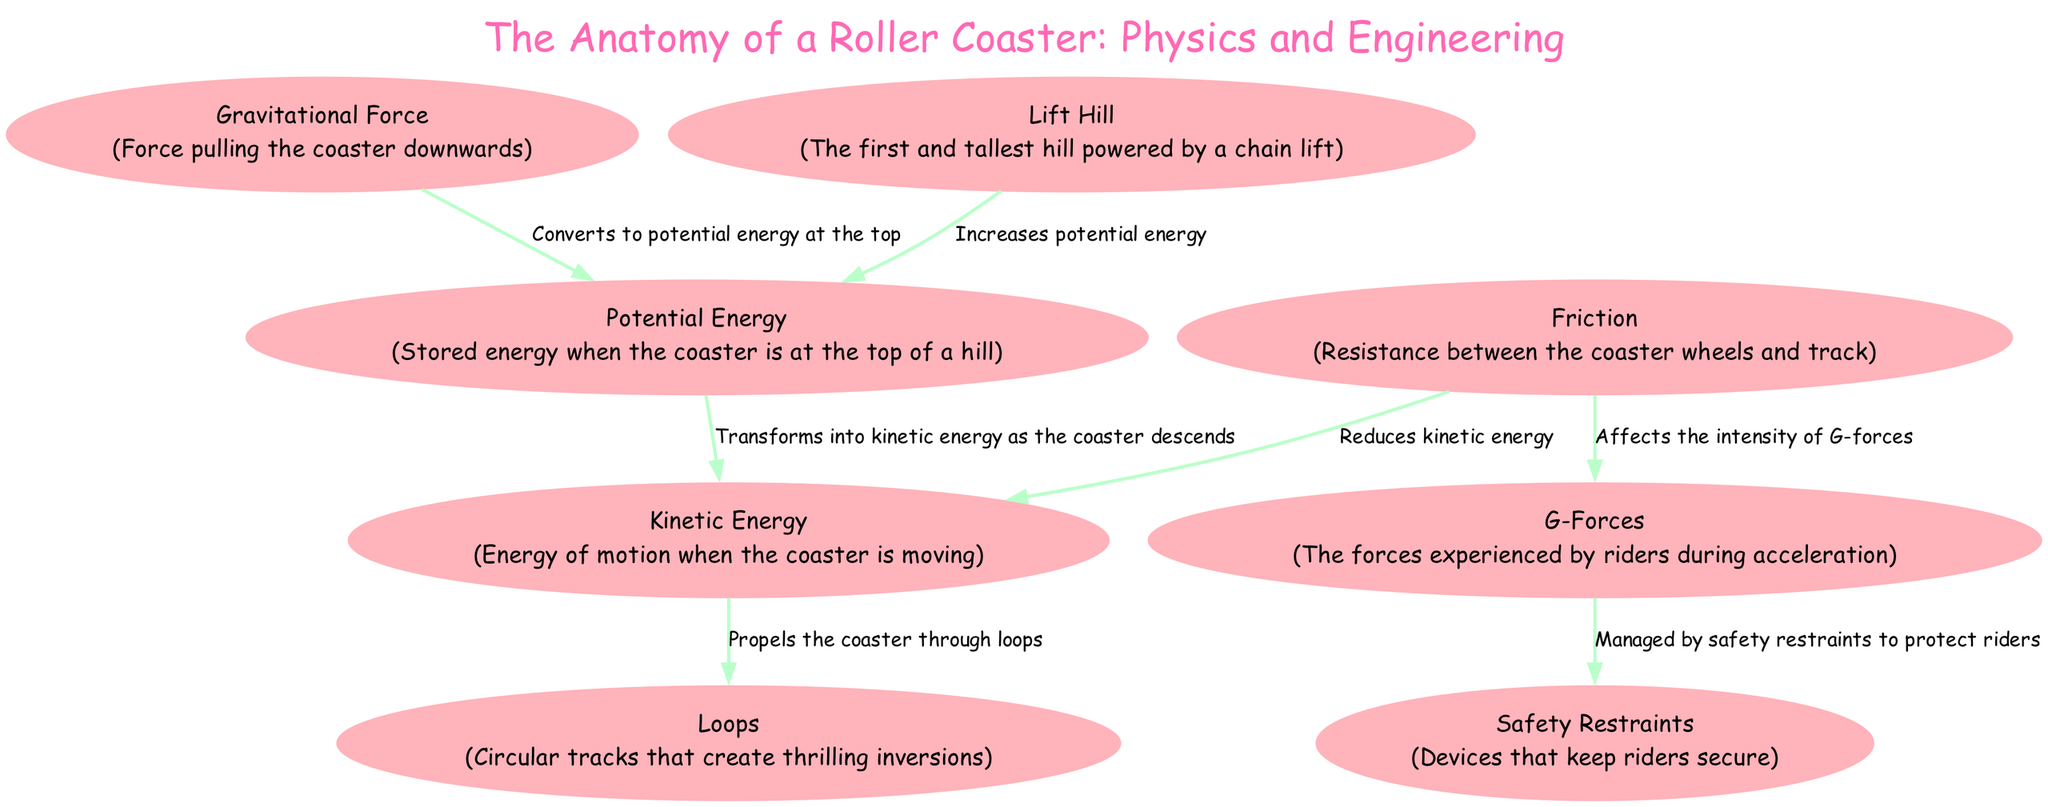What pulls the coaster downwards? The diagram identifies "Gravitational Force" as the force that pulls the coaster downwards.
Answer: Gravitational Force What increases when the coaster reaches the top of the hill? The diagram shows that "Potential Energy" increases when the coaster is at the top of the hill.
Answer: Potential Energy How many nodes are in the diagram? Counting the nodes listed in the diagram, there are a total of 8 nodes.
Answer: 8 What energy is transformed as the coaster descends? The diagram states that "Potential Energy" transforms into "Kinetic Energy" as the coaster descends.
Answer: Kinetic Energy What is affected by friction? According to the diagram, "G-Forces" are affected by friction, as friction influences the intensity of G-Forces during the ride.
Answer: G-Forces How does the lift hill impact potential energy? The "Lift Hill" is shown to increase "Potential Energy," indicating that the action of climbing this hill raises the stored energy of the coaster.
Answer: Increases Potential Energy What type of forces do riders experience during acceleration? The diagram defines "G-Forces" as the type of forces experienced by riders during acceleration and movement of the coaster.
Answer: G-Forces How do safety restraints relate to G-forces? The diagram depicts that "G-Forces" are managed by "Safety Restraints," ensuring the protection of riders against these forces.
Answer: Managed by Safety Restraints What happens to kinetic energy when friction is present? The relationship shown in the diagram indicates that "Friction" reduces "Kinetic Energy," suggesting that friction acts as a counterforce to the motion of the coaster.
Answer: Reduces Kinetic Energy 